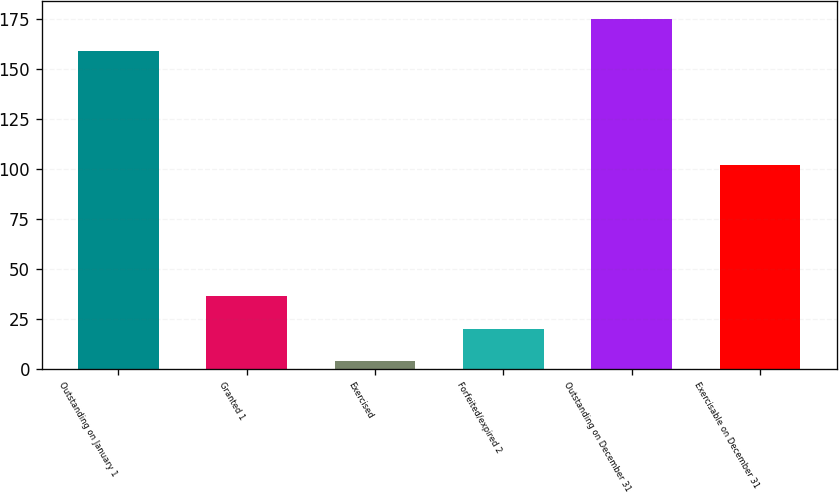Convert chart to OTSL. <chart><loc_0><loc_0><loc_500><loc_500><bar_chart><fcel>Outstanding on January 1<fcel>Granted 1<fcel>Exercised<fcel>Forfeited/expired 2<fcel>Outstanding on December 31<fcel>Exercisable on December 31<nl><fcel>159<fcel>36.6<fcel>4<fcel>20.3<fcel>175.3<fcel>102<nl></chart> 